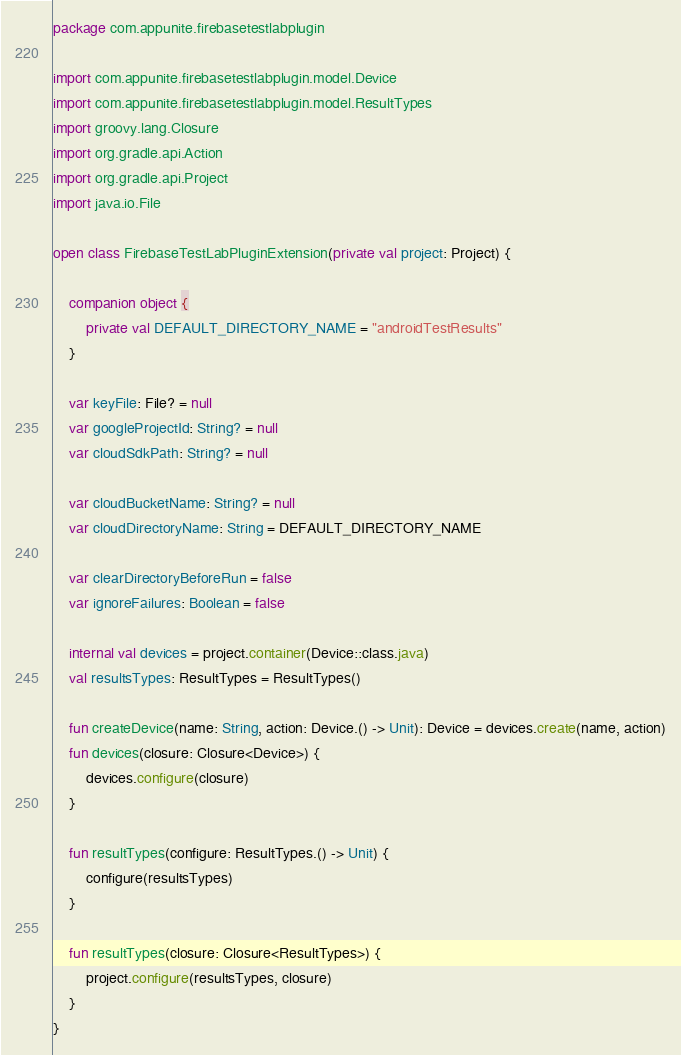<code> <loc_0><loc_0><loc_500><loc_500><_Kotlin_>package com.appunite.firebasetestlabplugin

import com.appunite.firebasetestlabplugin.model.Device
import com.appunite.firebasetestlabplugin.model.ResultTypes
import groovy.lang.Closure
import org.gradle.api.Action
import org.gradle.api.Project
import java.io.File

open class FirebaseTestLabPluginExtension(private val project: Project) {

    companion object {
        private val DEFAULT_DIRECTORY_NAME = "androidTestResults"
    }

    var keyFile: File? = null
    var googleProjectId: String? = null
    var cloudSdkPath: String? = null

    var cloudBucketName: String? = null
    var cloudDirectoryName: String = DEFAULT_DIRECTORY_NAME

    var clearDirectoryBeforeRun = false
    var ignoreFailures: Boolean = false

    internal val devices = project.container(Device::class.java)
    val resultsTypes: ResultTypes = ResultTypes()

    fun createDevice(name: String, action: Device.() -> Unit): Device = devices.create(name, action)
    fun devices(closure: Closure<Device>) {
        devices.configure(closure)
    }

    fun resultTypes(configure: ResultTypes.() -> Unit) {
        configure(resultsTypes)
    }

    fun resultTypes(closure: Closure<ResultTypes>) {
        project.configure(resultsTypes, closure)
    }
}</code> 